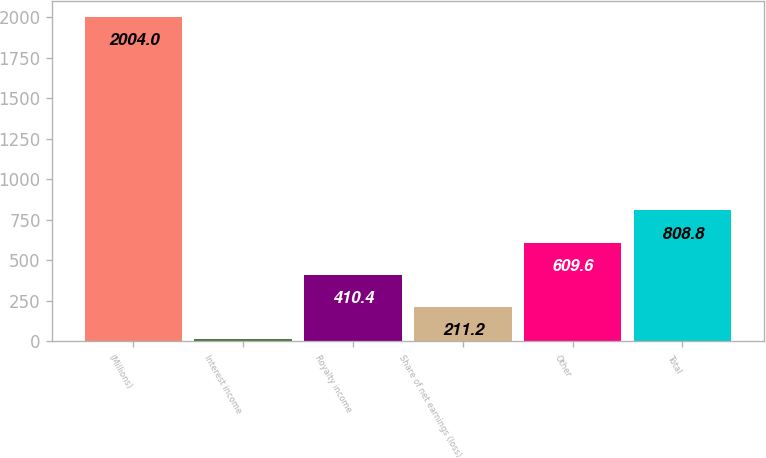<chart> <loc_0><loc_0><loc_500><loc_500><bar_chart><fcel>(Millions)<fcel>Interest income<fcel>Royalty income<fcel>Share of net earnings (loss)<fcel>Other<fcel>Total<nl><fcel>2004<fcel>12<fcel>410.4<fcel>211.2<fcel>609.6<fcel>808.8<nl></chart> 